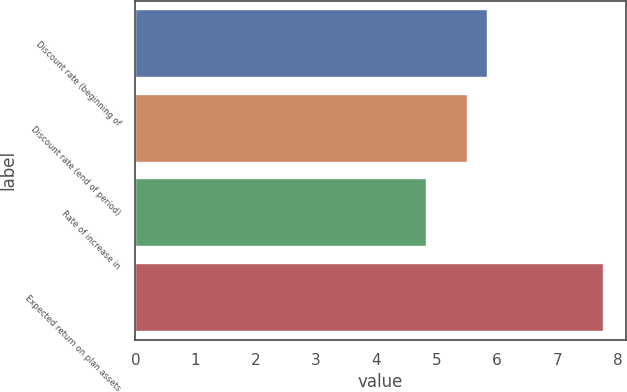Convert chart. <chart><loc_0><loc_0><loc_500><loc_500><bar_chart><fcel>Discount rate (beginning of<fcel>Discount rate (end of period)<fcel>Rate of increase in<fcel>Expected return on plan assets<nl><fcel>5.83<fcel>5.5<fcel>4.83<fcel>7.75<nl></chart> 